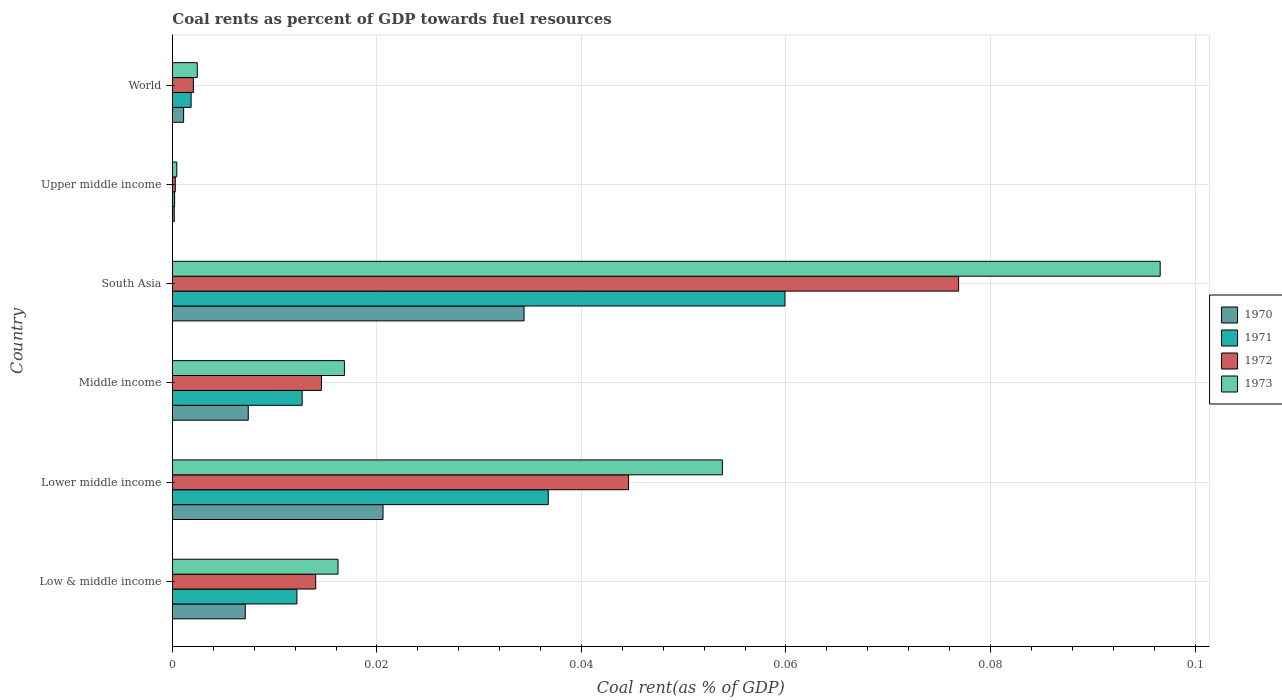Are the number of bars on each tick of the Y-axis equal?
Give a very brief answer. Yes. What is the coal rent in 1973 in Lower middle income?
Provide a succinct answer. 0.05. Across all countries, what is the maximum coal rent in 1973?
Your answer should be compact. 0.1. Across all countries, what is the minimum coal rent in 1970?
Your response must be concise. 0. In which country was the coal rent in 1971 minimum?
Give a very brief answer. Upper middle income. What is the total coal rent in 1971 in the graph?
Give a very brief answer. 0.12. What is the difference between the coal rent in 1970 in Low & middle income and that in Middle income?
Keep it short and to the point. -0. What is the difference between the coal rent in 1973 in Lower middle income and the coal rent in 1971 in Middle income?
Offer a very short reply. 0.04. What is the average coal rent in 1972 per country?
Keep it short and to the point. 0.03. What is the difference between the coal rent in 1970 and coal rent in 1971 in Upper middle income?
Your answer should be compact. -3.4968209641675e-5. In how many countries, is the coal rent in 1970 greater than 0.076 %?
Give a very brief answer. 0. What is the ratio of the coal rent in 1973 in South Asia to that in Upper middle income?
Make the answer very short. 224.18. What is the difference between the highest and the second highest coal rent in 1971?
Your response must be concise. 0.02. What is the difference between the highest and the lowest coal rent in 1970?
Offer a terse response. 0.03. Is the sum of the coal rent in 1973 in Low & middle income and South Asia greater than the maximum coal rent in 1971 across all countries?
Ensure brevity in your answer.  Yes. What does the 1st bar from the top in South Asia represents?
Give a very brief answer. 1973. What does the 2nd bar from the bottom in Lower middle income represents?
Your response must be concise. 1971. Are the values on the major ticks of X-axis written in scientific E-notation?
Keep it short and to the point. No. Does the graph contain grids?
Offer a very short reply. Yes. Where does the legend appear in the graph?
Your response must be concise. Center right. How are the legend labels stacked?
Give a very brief answer. Vertical. What is the title of the graph?
Keep it short and to the point. Coal rents as percent of GDP towards fuel resources. What is the label or title of the X-axis?
Ensure brevity in your answer.  Coal rent(as % of GDP). What is the Coal rent(as % of GDP) in 1970 in Low & middle income?
Keep it short and to the point. 0.01. What is the Coal rent(as % of GDP) of 1971 in Low & middle income?
Your answer should be compact. 0.01. What is the Coal rent(as % of GDP) in 1972 in Low & middle income?
Your answer should be compact. 0.01. What is the Coal rent(as % of GDP) in 1973 in Low & middle income?
Your response must be concise. 0.02. What is the Coal rent(as % of GDP) of 1970 in Lower middle income?
Make the answer very short. 0.02. What is the Coal rent(as % of GDP) in 1971 in Lower middle income?
Offer a terse response. 0.04. What is the Coal rent(as % of GDP) of 1972 in Lower middle income?
Give a very brief answer. 0.04. What is the Coal rent(as % of GDP) of 1973 in Lower middle income?
Give a very brief answer. 0.05. What is the Coal rent(as % of GDP) in 1970 in Middle income?
Your answer should be compact. 0.01. What is the Coal rent(as % of GDP) in 1971 in Middle income?
Offer a terse response. 0.01. What is the Coal rent(as % of GDP) of 1972 in Middle income?
Provide a short and direct response. 0.01. What is the Coal rent(as % of GDP) of 1973 in Middle income?
Provide a succinct answer. 0.02. What is the Coal rent(as % of GDP) in 1970 in South Asia?
Make the answer very short. 0.03. What is the Coal rent(as % of GDP) in 1971 in South Asia?
Keep it short and to the point. 0.06. What is the Coal rent(as % of GDP) in 1972 in South Asia?
Keep it short and to the point. 0.08. What is the Coal rent(as % of GDP) of 1973 in South Asia?
Keep it short and to the point. 0.1. What is the Coal rent(as % of GDP) in 1970 in Upper middle income?
Your answer should be very brief. 0. What is the Coal rent(as % of GDP) of 1971 in Upper middle income?
Ensure brevity in your answer.  0. What is the Coal rent(as % of GDP) of 1972 in Upper middle income?
Keep it short and to the point. 0. What is the Coal rent(as % of GDP) in 1973 in Upper middle income?
Your answer should be very brief. 0. What is the Coal rent(as % of GDP) of 1970 in World?
Offer a terse response. 0. What is the Coal rent(as % of GDP) of 1971 in World?
Make the answer very short. 0. What is the Coal rent(as % of GDP) of 1972 in World?
Make the answer very short. 0. What is the Coal rent(as % of GDP) in 1973 in World?
Provide a succinct answer. 0. Across all countries, what is the maximum Coal rent(as % of GDP) in 1970?
Keep it short and to the point. 0.03. Across all countries, what is the maximum Coal rent(as % of GDP) of 1971?
Give a very brief answer. 0.06. Across all countries, what is the maximum Coal rent(as % of GDP) in 1972?
Provide a succinct answer. 0.08. Across all countries, what is the maximum Coal rent(as % of GDP) of 1973?
Give a very brief answer. 0.1. Across all countries, what is the minimum Coal rent(as % of GDP) in 1970?
Offer a terse response. 0. Across all countries, what is the minimum Coal rent(as % of GDP) of 1971?
Keep it short and to the point. 0. Across all countries, what is the minimum Coal rent(as % of GDP) in 1972?
Offer a terse response. 0. Across all countries, what is the minimum Coal rent(as % of GDP) of 1973?
Provide a short and direct response. 0. What is the total Coal rent(as % of GDP) in 1970 in the graph?
Your response must be concise. 0.07. What is the total Coal rent(as % of GDP) of 1971 in the graph?
Ensure brevity in your answer.  0.12. What is the total Coal rent(as % of GDP) in 1972 in the graph?
Make the answer very short. 0.15. What is the total Coal rent(as % of GDP) in 1973 in the graph?
Give a very brief answer. 0.19. What is the difference between the Coal rent(as % of GDP) in 1970 in Low & middle income and that in Lower middle income?
Keep it short and to the point. -0.01. What is the difference between the Coal rent(as % of GDP) in 1971 in Low & middle income and that in Lower middle income?
Offer a very short reply. -0.02. What is the difference between the Coal rent(as % of GDP) of 1972 in Low & middle income and that in Lower middle income?
Give a very brief answer. -0.03. What is the difference between the Coal rent(as % of GDP) of 1973 in Low & middle income and that in Lower middle income?
Your answer should be compact. -0.04. What is the difference between the Coal rent(as % of GDP) of 1970 in Low & middle income and that in Middle income?
Your answer should be very brief. -0. What is the difference between the Coal rent(as % of GDP) in 1971 in Low & middle income and that in Middle income?
Ensure brevity in your answer.  -0. What is the difference between the Coal rent(as % of GDP) of 1972 in Low & middle income and that in Middle income?
Ensure brevity in your answer.  -0. What is the difference between the Coal rent(as % of GDP) in 1973 in Low & middle income and that in Middle income?
Offer a terse response. -0. What is the difference between the Coal rent(as % of GDP) of 1970 in Low & middle income and that in South Asia?
Give a very brief answer. -0.03. What is the difference between the Coal rent(as % of GDP) in 1971 in Low & middle income and that in South Asia?
Your answer should be compact. -0.05. What is the difference between the Coal rent(as % of GDP) in 1972 in Low & middle income and that in South Asia?
Your answer should be very brief. -0.06. What is the difference between the Coal rent(as % of GDP) of 1973 in Low & middle income and that in South Asia?
Offer a terse response. -0.08. What is the difference between the Coal rent(as % of GDP) of 1970 in Low & middle income and that in Upper middle income?
Make the answer very short. 0.01. What is the difference between the Coal rent(as % of GDP) of 1971 in Low & middle income and that in Upper middle income?
Provide a succinct answer. 0.01. What is the difference between the Coal rent(as % of GDP) of 1972 in Low & middle income and that in Upper middle income?
Provide a short and direct response. 0.01. What is the difference between the Coal rent(as % of GDP) in 1973 in Low & middle income and that in Upper middle income?
Your answer should be very brief. 0.02. What is the difference between the Coal rent(as % of GDP) of 1970 in Low & middle income and that in World?
Offer a terse response. 0.01. What is the difference between the Coal rent(as % of GDP) in 1971 in Low & middle income and that in World?
Provide a succinct answer. 0.01. What is the difference between the Coal rent(as % of GDP) in 1972 in Low & middle income and that in World?
Offer a very short reply. 0.01. What is the difference between the Coal rent(as % of GDP) of 1973 in Low & middle income and that in World?
Keep it short and to the point. 0.01. What is the difference between the Coal rent(as % of GDP) of 1970 in Lower middle income and that in Middle income?
Make the answer very short. 0.01. What is the difference between the Coal rent(as % of GDP) of 1971 in Lower middle income and that in Middle income?
Your answer should be very brief. 0.02. What is the difference between the Coal rent(as % of GDP) of 1973 in Lower middle income and that in Middle income?
Provide a succinct answer. 0.04. What is the difference between the Coal rent(as % of GDP) in 1970 in Lower middle income and that in South Asia?
Provide a succinct answer. -0.01. What is the difference between the Coal rent(as % of GDP) in 1971 in Lower middle income and that in South Asia?
Your answer should be very brief. -0.02. What is the difference between the Coal rent(as % of GDP) in 1972 in Lower middle income and that in South Asia?
Your answer should be compact. -0.03. What is the difference between the Coal rent(as % of GDP) in 1973 in Lower middle income and that in South Asia?
Your answer should be compact. -0.04. What is the difference between the Coal rent(as % of GDP) of 1970 in Lower middle income and that in Upper middle income?
Your answer should be compact. 0.02. What is the difference between the Coal rent(as % of GDP) of 1971 in Lower middle income and that in Upper middle income?
Offer a very short reply. 0.04. What is the difference between the Coal rent(as % of GDP) of 1972 in Lower middle income and that in Upper middle income?
Your answer should be compact. 0.04. What is the difference between the Coal rent(as % of GDP) in 1973 in Lower middle income and that in Upper middle income?
Offer a terse response. 0.05. What is the difference between the Coal rent(as % of GDP) in 1970 in Lower middle income and that in World?
Make the answer very short. 0.02. What is the difference between the Coal rent(as % of GDP) in 1971 in Lower middle income and that in World?
Provide a short and direct response. 0.03. What is the difference between the Coal rent(as % of GDP) in 1972 in Lower middle income and that in World?
Make the answer very short. 0.04. What is the difference between the Coal rent(as % of GDP) of 1973 in Lower middle income and that in World?
Your answer should be compact. 0.05. What is the difference between the Coal rent(as % of GDP) in 1970 in Middle income and that in South Asia?
Give a very brief answer. -0.03. What is the difference between the Coal rent(as % of GDP) of 1971 in Middle income and that in South Asia?
Offer a very short reply. -0.05. What is the difference between the Coal rent(as % of GDP) of 1972 in Middle income and that in South Asia?
Your response must be concise. -0.06. What is the difference between the Coal rent(as % of GDP) in 1973 in Middle income and that in South Asia?
Offer a very short reply. -0.08. What is the difference between the Coal rent(as % of GDP) in 1970 in Middle income and that in Upper middle income?
Keep it short and to the point. 0.01. What is the difference between the Coal rent(as % of GDP) in 1971 in Middle income and that in Upper middle income?
Your answer should be compact. 0.01. What is the difference between the Coal rent(as % of GDP) of 1972 in Middle income and that in Upper middle income?
Your response must be concise. 0.01. What is the difference between the Coal rent(as % of GDP) in 1973 in Middle income and that in Upper middle income?
Your answer should be compact. 0.02. What is the difference between the Coal rent(as % of GDP) of 1970 in Middle income and that in World?
Give a very brief answer. 0.01. What is the difference between the Coal rent(as % of GDP) of 1971 in Middle income and that in World?
Offer a terse response. 0.01. What is the difference between the Coal rent(as % of GDP) in 1972 in Middle income and that in World?
Offer a very short reply. 0.01. What is the difference between the Coal rent(as % of GDP) of 1973 in Middle income and that in World?
Your answer should be very brief. 0.01. What is the difference between the Coal rent(as % of GDP) in 1970 in South Asia and that in Upper middle income?
Your answer should be very brief. 0.03. What is the difference between the Coal rent(as % of GDP) in 1971 in South Asia and that in Upper middle income?
Give a very brief answer. 0.06. What is the difference between the Coal rent(as % of GDP) of 1972 in South Asia and that in Upper middle income?
Your answer should be very brief. 0.08. What is the difference between the Coal rent(as % of GDP) in 1973 in South Asia and that in Upper middle income?
Provide a short and direct response. 0.1. What is the difference between the Coal rent(as % of GDP) of 1971 in South Asia and that in World?
Provide a short and direct response. 0.06. What is the difference between the Coal rent(as % of GDP) of 1972 in South Asia and that in World?
Provide a succinct answer. 0.07. What is the difference between the Coal rent(as % of GDP) in 1973 in South Asia and that in World?
Provide a succinct answer. 0.09. What is the difference between the Coal rent(as % of GDP) of 1970 in Upper middle income and that in World?
Your response must be concise. -0. What is the difference between the Coal rent(as % of GDP) in 1971 in Upper middle income and that in World?
Ensure brevity in your answer.  -0. What is the difference between the Coal rent(as % of GDP) in 1972 in Upper middle income and that in World?
Offer a very short reply. -0. What is the difference between the Coal rent(as % of GDP) in 1973 in Upper middle income and that in World?
Offer a terse response. -0. What is the difference between the Coal rent(as % of GDP) of 1970 in Low & middle income and the Coal rent(as % of GDP) of 1971 in Lower middle income?
Make the answer very short. -0.03. What is the difference between the Coal rent(as % of GDP) of 1970 in Low & middle income and the Coal rent(as % of GDP) of 1972 in Lower middle income?
Keep it short and to the point. -0.04. What is the difference between the Coal rent(as % of GDP) in 1970 in Low & middle income and the Coal rent(as % of GDP) in 1973 in Lower middle income?
Your answer should be compact. -0.05. What is the difference between the Coal rent(as % of GDP) in 1971 in Low & middle income and the Coal rent(as % of GDP) in 1972 in Lower middle income?
Your response must be concise. -0.03. What is the difference between the Coal rent(as % of GDP) of 1971 in Low & middle income and the Coal rent(as % of GDP) of 1973 in Lower middle income?
Ensure brevity in your answer.  -0.04. What is the difference between the Coal rent(as % of GDP) of 1972 in Low & middle income and the Coal rent(as % of GDP) of 1973 in Lower middle income?
Your answer should be very brief. -0.04. What is the difference between the Coal rent(as % of GDP) of 1970 in Low & middle income and the Coal rent(as % of GDP) of 1971 in Middle income?
Provide a succinct answer. -0.01. What is the difference between the Coal rent(as % of GDP) in 1970 in Low & middle income and the Coal rent(as % of GDP) in 1972 in Middle income?
Your answer should be compact. -0.01. What is the difference between the Coal rent(as % of GDP) of 1970 in Low & middle income and the Coal rent(as % of GDP) of 1973 in Middle income?
Your response must be concise. -0.01. What is the difference between the Coal rent(as % of GDP) in 1971 in Low & middle income and the Coal rent(as % of GDP) in 1972 in Middle income?
Provide a short and direct response. -0. What is the difference between the Coal rent(as % of GDP) in 1971 in Low & middle income and the Coal rent(as % of GDP) in 1973 in Middle income?
Your answer should be compact. -0. What is the difference between the Coal rent(as % of GDP) of 1972 in Low & middle income and the Coal rent(as % of GDP) of 1973 in Middle income?
Your response must be concise. -0. What is the difference between the Coal rent(as % of GDP) in 1970 in Low & middle income and the Coal rent(as % of GDP) in 1971 in South Asia?
Provide a succinct answer. -0.05. What is the difference between the Coal rent(as % of GDP) in 1970 in Low & middle income and the Coal rent(as % of GDP) in 1972 in South Asia?
Make the answer very short. -0.07. What is the difference between the Coal rent(as % of GDP) in 1970 in Low & middle income and the Coal rent(as % of GDP) in 1973 in South Asia?
Your response must be concise. -0.09. What is the difference between the Coal rent(as % of GDP) of 1971 in Low & middle income and the Coal rent(as % of GDP) of 1972 in South Asia?
Make the answer very short. -0.06. What is the difference between the Coal rent(as % of GDP) in 1971 in Low & middle income and the Coal rent(as % of GDP) in 1973 in South Asia?
Give a very brief answer. -0.08. What is the difference between the Coal rent(as % of GDP) in 1972 in Low & middle income and the Coal rent(as % of GDP) in 1973 in South Asia?
Make the answer very short. -0.08. What is the difference between the Coal rent(as % of GDP) in 1970 in Low & middle income and the Coal rent(as % of GDP) in 1971 in Upper middle income?
Offer a very short reply. 0.01. What is the difference between the Coal rent(as % of GDP) of 1970 in Low & middle income and the Coal rent(as % of GDP) of 1972 in Upper middle income?
Provide a succinct answer. 0.01. What is the difference between the Coal rent(as % of GDP) of 1970 in Low & middle income and the Coal rent(as % of GDP) of 1973 in Upper middle income?
Provide a short and direct response. 0.01. What is the difference between the Coal rent(as % of GDP) in 1971 in Low & middle income and the Coal rent(as % of GDP) in 1972 in Upper middle income?
Provide a short and direct response. 0.01. What is the difference between the Coal rent(as % of GDP) of 1971 in Low & middle income and the Coal rent(as % of GDP) of 1973 in Upper middle income?
Provide a succinct answer. 0.01. What is the difference between the Coal rent(as % of GDP) in 1972 in Low & middle income and the Coal rent(as % of GDP) in 1973 in Upper middle income?
Your response must be concise. 0.01. What is the difference between the Coal rent(as % of GDP) in 1970 in Low & middle income and the Coal rent(as % of GDP) in 1971 in World?
Ensure brevity in your answer.  0.01. What is the difference between the Coal rent(as % of GDP) of 1970 in Low & middle income and the Coal rent(as % of GDP) of 1972 in World?
Offer a very short reply. 0.01. What is the difference between the Coal rent(as % of GDP) of 1970 in Low & middle income and the Coal rent(as % of GDP) of 1973 in World?
Your response must be concise. 0. What is the difference between the Coal rent(as % of GDP) of 1971 in Low & middle income and the Coal rent(as % of GDP) of 1972 in World?
Offer a terse response. 0.01. What is the difference between the Coal rent(as % of GDP) in 1971 in Low & middle income and the Coal rent(as % of GDP) in 1973 in World?
Ensure brevity in your answer.  0.01. What is the difference between the Coal rent(as % of GDP) of 1972 in Low & middle income and the Coal rent(as % of GDP) of 1973 in World?
Give a very brief answer. 0.01. What is the difference between the Coal rent(as % of GDP) of 1970 in Lower middle income and the Coal rent(as % of GDP) of 1971 in Middle income?
Your answer should be compact. 0.01. What is the difference between the Coal rent(as % of GDP) in 1970 in Lower middle income and the Coal rent(as % of GDP) in 1972 in Middle income?
Offer a terse response. 0.01. What is the difference between the Coal rent(as % of GDP) of 1970 in Lower middle income and the Coal rent(as % of GDP) of 1973 in Middle income?
Ensure brevity in your answer.  0. What is the difference between the Coal rent(as % of GDP) of 1971 in Lower middle income and the Coal rent(as % of GDP) of 1972 in Middle income?
Your answer should be compact. 0.02. What is the difference between the Coal rent(as % of GDP) of 1971 in Lower middle income and the Coal rent(as % of GDP) of 1973 in Middle income?
Offer a terse response. 0.02. What is the difference between the Coal rent(as % of GDP) of 1972 in Lower middle income and the Coal rent(as % of GDP) of 1973 in Middle income?
Offer a terse response. 0.03. What is the difference between the Coal rent(as % of GDP) of 1970 in Lower middle income and the Coal rent(as % of GDP) of 1971 in South Asia?
Your answer should be compact. -0.04. What is the difference between the Coal rent(as % of GDP) in 1970 in Lower middle income and the Coal rent(as % of GDP) in 1972 in South Asia?
Ensure brevity in your answer.  -0.06. What is the difference between the Coal rent(as % of GDP) in 1970 in Lower middle income and the Coal rent(as % of GDP) in 1973 in South Asia?
Provide a short and direct response. -0.08. What is the difference between the Coal rent(as % of GDP) of 1971 in Lower middle income and the Coal rent(as % of GDP) of 1972 in South Asia?
Ensure brevity in your answer.  -0.04. What is the difference between the Coal rent(as % of GDP) of 1971 in Lower middle income and the Coal rent(as % of GDP) of 1973 in South Asia?
Keep it short and to the point. -0.06. What is the difference between the Coal rent(as % of GDP) of 1972 in Lower middle income and the Coal rent(as % of GDP) of 1973 in South Asia?
Your answer should be compact. -0.05. What is the difference between the Coal rent(as % of GDP) of 1970 in Lower middle income and the Coal rent(as % of GDP) of 1971 in Upper middle income?
Provide a succinct answer. 0.02. What is the difference between the Coal rent(as % of GDP) in 1970 in Lower middle income and the Coal rent(as % of GDP) in 1972 in Upper middle income?
Offer a very short reply. 0.02. What is the difference between the Coal rent(as % of GDP) in 1970 in Lower middle income and the Coal rent(as % of GDP) in 1973 in Upper middle income?
Provide a succinct answer. 0.02. What is the difference between the Coal rent(as % of GDP) in 1971 in Lower middle income and the Coal rent(as % of GDP) in 1972 in Upper middle income?
Provide a succinct answer. 0.04. What is the difference between the Coal rent(as % of GDP) of 1971 in Lower middle income and the Coal rent(as % of GDP) of 1973 in Upper middle income?
Ensure brevity in your answer.  0.04. What is the difference between the Coal rent(as % of GDP) in 1972 in Lower middle income and the Coal rent(as % of GDP) in 1973 in Upper middle income?
Give a very brief answer. 0.04. What is the difference between the Coal rent(as % of GDP) of 1970 in Lower middle income and the Coal rent(as % of GDP) of 1971 in World?
Ensure brevity in your answer.  0.02. What is the difference between the Coal rent(as % of GDP) in 1970 in Lower middle income and the Coal rent(as % of GDP) in 1972 in World?
Make the answer very short. 0.02. What is the difference between the Coal rent(as % of GDP) of 1970 in Lower middle income and the Coal rent(as % of GDP) of 1973 in World?
Make the answer very short. 0.02. What is the difference between the Coal rent(as % of GDP) in 1971 in Lower middle income and the Coal rent(as % of GDP) in 1972 in World?
Your answer should be very brief. 0.03. What is the difference between the Coal rent(as % of GDP) of 1971 in Lower middle income and the Coal rent(as % of GDP) of 1973 in World?
Offer a very short reply. 0.03. What is the difference between the Coal rent(as % of GDP) in 1972 in Lower middle income and the Coal rent(as % of GDP) in 1973 in World?
Your answer should be compact. 0.04. What is the difference between the Coal rent(as % of GDP) in 1970 in Middle income and the Coal rent(as % of GDP) in 1971 in South Asia?
Ensure brevity in your answer.  -0.05. What is the difference between the Coal rent(as % of GDP) in 1970 in Middle income and the Coal rent(as % of GDP) in 1972 in South Asia?
Offer a very short reply. -0.07. What is the difference between the Coal rent(as % of GDP) of 1970 in Middle income and the Coal rent(as % of GDP) of 1973 in South Asia?
Provide a short and direct response. -0.09. What is the difference between the Coal rent(as % of GDP) in 1971 in Middle income and the Coal rent(as % of GDP) in 1972 in South Asia?
Your answer should be very brief. -0.06. What is the difference between the Coal rent(as % of GDP) in 1971 in Middle income and the Coal rent(as % of GDP) in 1973 in South Asia?
Ensure brevity in your answer.  -0.08. What is the difference between the Coal rent(as % of GDP) of 1972 in Middle income and the Coal rent(as % of GDP) of 1973 in South Asia?
Keep it short and to the point. -0.08. What is the difference between the Coal rent(as % of GDP) of 1970 in Middle income and the Coal rent(as % of GDP) of 1971 in Upper middle income?
Provide a short and direct response. 0.01. What is the difference between the Coal rent(as % of GDP) of 1970 in Middle income and the Coal rent(as % of GDP) of 1972 in Upper middle income?
Offer a terse response. 0.01. What is the difference between the Coal rent(as % of GDP) of 1970 in Middle income and the Coal rent(as % of GDP) of 1973 in Upper middle income?
Ensure brevity in your answer.  0.01. What is the difference between the Coal rent(as % of GDP) of 1971 in Middle income and the Coal rent(as % of GDP) of 1972 in Upper middle income?
Your answer should be very brief. 0.01. What is the difference between the Coal rent(as % of GDP) of 1971 in Middle income and the Coal rent(as % of GDP) of 1973 in Upper middle income?
Your answer should be compact. 0.01. What is the difference between the Coal rent(as % of GDP) of 1972 in Middle income and the Coal rent(as % of GDP) of 1973 in Upper middle income?
Your answer should be compact. 0.01. What is the difference between the Coal rent(as % of GDP) in 1970 in Middle income and the Coal rent(as % of GDP) in 1971 in World?
Offer a terse response. 0.01. What is the difference between the Coal rent(as % of GDP) of 1970 in Middle income and the Coal rent(as % of GDP) of 1972 in World?
Give a very brief answer. 0.01. What is the difference between the Coal rent(as % of GDP) in 1970 in Middle income and the Coal rent(as % of GDP) in 1973 in World?
Offer a very short reply. 0.01. What is the difference between the Coal rent(as % of GDP) in 1971 in Middle income and the Coal rent(as % of GDP) in 1972 in World?
Offer a terse response. 0.01. What is the difference between the Coal rent(as % of GDP) of 1971 in Middle income and the Coal rent(as % of GDP) of 1973 in World?
Keep it short and to the point. 0.01. What is the difference between the Coal rent(as % of GDP) of 1972 in Middle income and the Coal rent(as % of GDP) of 1973 in World?
Provide a short and direct response. 0.01. What is the difference between the Coal rent(as % of GDP) of 1970 in South Asia and the Coal rent(as % of GDP) of 1971 in Upper middle income?
Your response must be concise. 0.03. What is the difference between the Coal rent(as % of GDP) of 1970 in South Asia and the Coal rent(as % of GDP) of 1972 in Upper middle income?
Provide a succinct answer. 0.03. What is the difference between the Coal rent(as % of GDP) in 1970 in South Asia and the Coal rent(as % of GDP) in 1973 in Upper middle income?
Offer a terse response. 0.03. What is the difference between the Coal rent(as % of GDP) in 1971 in South Asia and the Coal rent(as % of GDP) in 1972 in Upper middle income?
Your response must be concise. 0.06. What is the difference between the Coal rent(as % of GDP) in 1971 in South Asia and the Coal rent(as % of GDP) in 1973 in Upper middle income?
Offer a very short reply. 0.06. What is the difference between the Coal rent(as % of GDP) in 1972 in South Asia and the Coal rent(as % of GDP) in 1973 in Upper middle income?
Your answer should be very brief. 0.08. What is the difference between the Coal rent(as % of GDP) of 1970 in South Asia and the Coal rent(as % of GDP) of 1971 in World?
Give a very brief answer. 0.03. What is the difference between the Coal rent(as % of GDP) in 1970 in South Asia and the Coal rent(as % of GDP) in 1972 in World?
Offer a very short reply. 0.03. What is the difference between the Coal rent(as % of GDP) in 1970 in South Asia and the Coal rent(as % of GDP) in 1973 in World?
Your answer should be compact. 0.03. What is the difference between the Coal rent(as % of GDP) in 1971 in South Asia and the Coal rent(as % of GDP) in 1972 in World?
Provide a short and direct response. 0.06. What is the difference between the Coal rent(as % of GDP) in 1971 in South Asia and the Coal rent(as % of GDP) in 1973 in World?
Give a very brief answer. 0.06. What is the difference between the Coal rent(as % of GDP) in 1972 in South Asia and the Coal rent(as % of GDP) in 1973 in World?
Offer a terse response. 0.07. What is the difference between the Coal rent(as % of GDP) of 1970 in Upper middle income and the Coal rent(as % of GDP) of 1971 in World?
Make the answer very short. -0. What is the difference between the Coal rent(as % of GDP) of 1970 in Upper middle income and the Coal rent(as % of GDP) of 1972 in World?
Provide a short and direct response. -0. What is the difference between the Coal rent(as % of GDP) of 1970 in Upper middle income and the Coal rent(as % of GDP) of 1973 in World?
Make the answer very short. -0. What is the difference between the Coal rent(as % of GDP) in 1971 in Upper middle income and the Coal rent(as % of GDP) in 1972 in World?
Keep it short and to the point. -0. What is the difference between the Coal rent(as % of GDP) of 1971 in Upper middle income and the Coal rent(as % of GDP) of 1973 in World?
Ensure brevity in your answer.  -0. What is the difference between the Coal rent(as % of GDP) of 1972 in Upper middle income and the Coal rent(as % of GDP) of 1973 in World?
Your response must be concise. -0. What is the average Coal rent(as % of GDP) of 1970 per country?
Make the answer very short. 0.01. What is the average Coal rent(as % of GDP) of 1971 per country?
Offer a terse response. 0.02. What is the average Coal rent(as % of GDP) of 1972 per country?
Provide a short and direct response. 0.03. What is the average Coal rent(as % of GDP) in 1973 per country?
Your response must be concise. 0.03. What is the difference between the Coal rent(as % of GDP) in 1970 and Coal rent(as % of GDP) in 1971 in Low & middle income?
Offer a very short reply. -0.01. What is the difference between the Coal rent(as % of GDP) of 1970 and Coal rent(as % of GDP) of 1972 in Low & middle income?
Your answer should be very brief. -0.01. What is the difference between the Coal rent(as % of GDP) of 1970 and Coal rent(as % of GDP) of 1973 in Low & middle income?
Give a very brief answer. -0.01. What is the difference between the Coal rent(as % of GDP) in 1971 and Coal rent(as % of GDP) in 1972 in Low & middle income?
Offer a terse response. -0. What is the difference between the Coal rent(as % of GDP) of 1971 and Coal rent(as % of GDP) of 1973 in Low & middle income?
Provide a succinct answer. -0. What is the difference between the Coal rent(as % of GDP) in 1972 and Coal rent(as % of GDP) in 1973 in Low & middle income?
Make the answer very short. -0. What is the difference between the Coal rent(as % of GDP) in 1970 and Coal rent(as % of GDP) in 1971 in Lower middle income?
Offer a very short reply. -0.02. What is the difference between the Coal rent(as % of GDP) of 1970 and Coal rent(as % of GDP) of 1972 in Lower middle income?
Make the answer very short. -0.02. What is the difference between the Coal rent(as % of GDP) in 1970 and Coal rent(as % of GDP) in 1973 in Lower middle income?
Make the answer very short. -0.03. What is the difference between the Coal rent(as % of GDP) of 1971 and Coal rent(as % of GDP) of 1972 in Lower middle income?
Offer a terse response. -0.01. What is the difference between the Coal rent(as % of GDP) in 1971 and Coal rent(as % of GDP) in 1973 in Lower middle income?
Give a very brief answer. -0.02. What is the difference between the Coal rent(as % of GDP) of 1972 and Coal rent(as % of GDP) of 1973 in Lower middle income?
Provide a short and direct response. -0.01. What is the difference between the Coal rent(as % of GDP) of 1970 and Coal rent(as % of GDP) of 1971 in Middle income?
Ensure brevity in your answer.  -0.01. What is the difference between the Coal rent(as % of GDP) of 1970 and Coal rent(as % of GDP) of 1972 in Middle income?
Provide a succinct answer. -0.01. What is the difference between the Coal rent(as % of GDP) in 1970 and Coal rent(as % of GDP) in 1973 in Middle income?
Your answer should be very brief. -0.01. What is the difference between the Coal rent(as % of GDP) in 1971 and Coal rent(as % of GDP) in 1972 in Middle income?
Ensure brevity in your answer.  -0. What is the difference between the Coal rent(as % of GDP) in 1971 and Coal rent(as % of GDP) in 1973 in Middle income?
Provide a short and direct response. -0. What is the difference between the Coal rent(as % of GDP) of 1972 and Coal rent(as % of GDP) of 1973 in Middle income?
Make the answer very short. -0. What is the difference between the Coal rent(as % of GDP) in 1970 and Coal rent(as % of GDP) in 1971 in South Asia?
Your answer should be compact. -0.03. What is the difference between the Coal rent(as % of GDP) of 1970 and Coal rent(as % of GDP) of 1972 in South Asia?
Offer a terse response. -0.04. What is the difference between the Coal rent(as % of GDP) of 1970 and Coal rent(as % of GDP) of 1973 in South Asia?
Your response must be concise. -0.06. What is the difference between the Coal rent(as % of GDP) in 1971 and Coal rent(as % of GDP) in 1972 in South Asia?
Your answer should be compact. -0.02. What is the difference between the Coal rent(as % of GDP) in 1971 and Coal rent(as % of GDP) in 1973 in South Asia?
Ensure brevity in your answer.  -0.04. What is the difference between the Coal rent(as % of GDP) of 1972 and Coal rent(as % of GDP) of 1973 in South Asia?
Provide a succinct answer. -0.02. What is the difference between the Coal rent(as % of GDP) in 1970 and Coal rent(as % of GDP) in 1972 in Upper middle income?
Your answer should be compact. -0. What is the difference between the Coal rent(as % of GDP) of 1970 and Coal rent(as % of GDP) of 1973 in Upper middle income?
Offer a very short reply. -0. What is the difference between the Coal rent(as % of GDP) of 1971 and Coal rent(as % of GDP) of 1972 in Upper middle income?
Make the answer very short. -0. What is the difference between the Coal rent(as % of GDP) in 1971 and Coal rent(as % of GDP) in 1973 in Upper middle income?
Provide a succinct answer. -0. What is the difference between the Coal rent(as % of GDP) of 1972 and Coal rent(as % of GDP) of 1973 in Upper middle income?
Provide a succinct answer. -0. What is the difference between the Coal rent(as % of GDP) of 1970 and Coal rent(as % of GDP) of 1971 in World?
Give a very brief answer. -0. What is the difference between the Coal rent(as % of GDP) in 1970 and Coal rent(as % of GDP) in 1972 in World?
Give a very brief answer. -0. What is the difference between the Coal rent(as % of GDP) of 1970 and Coal rent(as % of GDP) of 1973 in World?
Provide a succinct answer. -0. What is the difference between the Coal rent(as % of GDP) of 1971 and Coal rent(as % of GDP) of 1972 in World?
Your answer should be very brief. -0. What is the difference between the Coal rent(as % of GDP) in 1971 and Coal rent(as % of GDP) in 1973 in World?
Provide a succinct answer. -0. What is the difference between the Coal rent(as % of GDP) in 1972 and Coal rent(as % of GDP) in 1973 in World?
Your answer should be compact. -0. What is the ratio of the Coal rent(as % of GDP) of 1970 in Low & middle income to that in Lower middle income?
Your answer should be very brief. 0.35. What is the ratio of the Coal rent(as % of GDP) in 1971 in Low & middle income to that in Lower middle income?
Offer a very short reply. 0.33. What is the ratio of the Coal rent(as % of GDP) of 1972 in Low & middle income to that in Lower middle income?
Make the answer very short. 0.31. What is the ratio of the Coal rent(as % of GDP) in 1973 in Low & middle income to that in Lower middle income?
Your response must be concise. 0.3. What is the ratio of the Coal rent(as % of GDP) in 1970 in Low & middle income to that in Middle income?
Make the answer very short. 0.96. What is the ratio of the Coal rent(as % of GDP) of 1971 in Low & middle income to that in Middle income?
Provide a succinct answer. 0.96. What is the ratio of the Coal rent(as % of GDP) in 1972 in Low & middle income to that in Middle income?
Give a very brief answer. 0.96. What is the ratio of the Coal rent(as % of GDP) of 1973 in Low & middle income to that in Middle income?
Your response must be concise. 0.96. What is the ratio of the Coal rent(as % of GDP) of 1970 in Low & middle income to that in South Asia?
Provide a short and direct response. 0.21. What is the ratio of the Coal rent(as % of GDP) of 1971 in Low & middle income to that in South Asia?
Provide a succinct answer. 0.2. What is the ratio of the Coal rent(as % of GDP) of 1972 in Low & middle income to that in South Asia?
Your answer should be very brief. 0.18. What is the ratio of the Coal rent(as % of GDP) in 1973 in Low & middle income to that in South Asia?
Provide a succinct answer. 0.17. What is the ratio of the Coal rent(as % of GDP) in 1970 in Low & middle income to that in Upper middle income?
Give a very brief answer. 38.77. What is the ratio of the Coal rent(as % of GDP) of 1971 in Low & middle income to that in Upper middle income?
Give a very brief answer. 55.66. What is the ratio of the Coal rent(as % of GDP) of 1972 in Low & middle income to that in Upper middle income?
Your answer should be compact. 49.28. What is the ratio of the Coal rent(as % of GDP) in 1973 in Low & middle income to that in Upper middle income?
Give a very brief answer. 37.59. What is the ratio of the Coal rent(as % of GDP) in 1970 in Low & middle income to that in World?
Give a very brief answer. 6.48. What is the ratio of the Coal rent(as % of GDP) in 1971 in Low & middle income to that in World?
Make the answer very short. 6.65. What is the ratio of the Coal rent(as % of GDP) of 1972 in Low & middle income to that in World?
Give a very brief answer. 6.82. What is the ratio of the Coal rent(as % of GDP) of 1973 in Low & middle income to that in World?
Your response must be concise. 6.65. What is the ratio of the Coal rent(as % of GDP) in 1970 in Lower middle income to that in Middle income?
Offer a terse response. 2.78. What is the ratio of the Coal rent(as % of GDP) of 1971 in Lower middle income to that in Middle income?
Your answer should be compact. 2.9. What is the ratio of the Coal rent(as % of GDP) in 1972 in Lower middle income to that in Middle income?
Offer a very short reply. 3.06. What is the ratio of the Coal rent(as % of GDP) of 1973 in Lower middle income to that in Middle income?
Offer a very short reply. 3.2. What is the ratio of the Coal rent(as % of GDP) of 1970 in Lower middle income to that in South Asia?
Your answer should be compact. 0.6. What is the ratio of the Coal rent(as % of GDP) of 1971 in Lower middle income to that in South Asia?
Give a very brief answer. 0.61. What is the ratio of the Coal rent(as % of GDP) in 1972 in Lower middle income to that in South Asia?
Provide a short and direct response. 0.58. What is the ratio of the Coal rent(as % of GDP) of 1973 in Lower middle income to that in South Asia?
Make the answer very short. 0.56. What is the ratio of the Coal rent(as % of GDP) of 1970 in Lower middle income to that in Upper middle income?
Make the answer very short. 112.03. What is the ratio of the Coal rent(as % of GDP) of 1971 in Lower middle income to that in Upper middle income?
Give a very brief answer. 167.98. What is the ratio of the Coal rent(as % of GDP) of 1972 in Lower middle income to that in Upper middle income?
Provide a short and direct response. 156.82. What is the ratio of the Coal rent(as % of GDP) of 1973 in Lower middle income to that in Upper middle income?
Your answer should be very brief. 124.82. What is the ratio of the Coal rent(as % of GDP) in 1970 in Lower middle income to that in World?
Offer a terse response. 18.71. What is the ratio of the Coal rent(as % of GDP) in 1971 in Lower middle income to that in World?
Give a very brief answer. 20.06. What is the ratio of the Coal rent(as % of GDP) in 1972 in Lower middle income to that in World?
Provide a short and direct response. 21.7. What is the ratio of the Coal rent(as % of GDP) of 1973 in Lower middle income to that in World?
Your answer should be very brief. 22.07. What is the ratio of the Coal rent(as % of GDP) of 1970 in Middle income to that in South Asia?
Give a very brief answer. 0.22. What is the ratio of the Coal rent(as % of GDP) in 1971 in Middle income to that in South Asia?
Provide a succinct answer. 0.21. What is the ratio of the Coal rent(as % of GDP) of 1972 in Middle income to that in South Asia?
Make the answer very short. 0.19. What is the ratio of the Coal rent(as % of GDP) of 1973 in Middle income to that in South Asia?
Provide a succinct answer. 0.17. What is the ratio of the Coal rent(as % of GDP) of 1970 in Middle income to that in Upper middle income?
Provide a succinct answer. 40.36. What is the ratio of the Coal rent(as % of GDP) of 1971 in Middle income to that in Upper middle income?
Give a very brief answer. 58.01. What is the ratio of the Coal rent(as % of GDP) of 1972 in Middle income to that in Upper middle income?
Offer a very short reply. 51.25. What is the ratio of the Coal rent(as % of GDP) in 1973 in Middle income to that in Upper middle income?
Make the answer very short. 39.04. What is the ratio of the Coal rent(as % of GDP) in 1970 in Middle income to that in World?
Offer a terse response. 6.74. What is the ratio of the Coal rent(as % of GDP) in 1971 in Middle income to that in World?
Provide a short and direct response. 6.93. What is the ratio of the Coal rent(as % of GDP) in 1972 in Middle income to that in World?
Your answer should be compact. 7.09. What is the ratio of the Coal rent(as % of GDP) of 1973 in Middle income to that in World?
Your answer should be very brief. 6.91. What is the ratio of the Coal rent(as % of GDP) of 1970 in South Asia to that in Upper middle income?
Keep it short and to the point. 187.05. What is the ratio of the Coal rent(as % of GDP) in 1971 in South Asia to that in Upper middle income?
Your answer should be very brief. 273.74. What is the ratio of the Coal rent(as % of GDP) in 1972 in South Asia to that in Upper middle income?
Your response must be concise. 270.32. What is the ratio of the Coal rent(as % of GDP) of 1973 in South Asia to that in Upper middle income?
Your answer should be compact. 224.18. What is the ratio of the Coal rent(as % of GDP) in 1970 in South Asia to that in World?
Your answer should be very brief. 31.24. What is the ratio of the Coal rent(as % of GDP) of 1971 in South Asia to that in World?
Your response must be concise. 32.69. What is the ratio of the Coal rent(as % of GDP) of 1972 in South Asia to that in World?
Provide a succinct answer. 37.41. What is the ratio of the Coal rent(as % of GDP) in 1973 in South Asia to that in World?
Ensure brevity in your answer.  39.65. What is the ratio of the Coal rent(as % of GDP) of 1970 in Upper middle income to that in World?
Provide a short and direct response. 0.17. What is the ratio of the Coal rent(as % of GDP) in 1971 in Upper middle income to that in World?
Provide a succinct answer. 0.12. What is the ratio of the Coal rent(as % of GDP) of 1972 in Upper middle income to that in World?
Keep it short and to the point. 0.14. What is the ratio of the Coal rent(as % of GDP) of 1973 in Upper middle income to that in World?
Provide a short and direct response. 0.18. What is the difference between the highest and the second highest Coal rent(as % of GDP) in 1970?
Provide a short and direct response. 0.01. What is the difference between the highest and the second highest Coal rent(as % of GDP) in 1971?
Give a very brief answer. 0.02. What is the difference between the highest and the second highest Coal rent(as % of GDP) of 1972?
Offer a terse response. 0.03. What is the difference between the highest and the second highest Coal rent(as % of GDP) of 1973?
Make the answer very short. 0.04. What is the difference between the highest and the lowest Coal rent(as % of GDP) of 1970?
Give a very brief answer. 0.03. What is the difference between the highest and the lowest Coal rent(as % of GDP) of 1971?
Your answer should be compact. 0.06. What is the difference between the highest and the lowest Coal rent(as % of GDP) of 1972?
Your answer should be very brief. 0.08. What is the difference between the highest and the lowest Coal rent(as % of GDP) of 1973?
Keep it short and to the point. 0.1. 